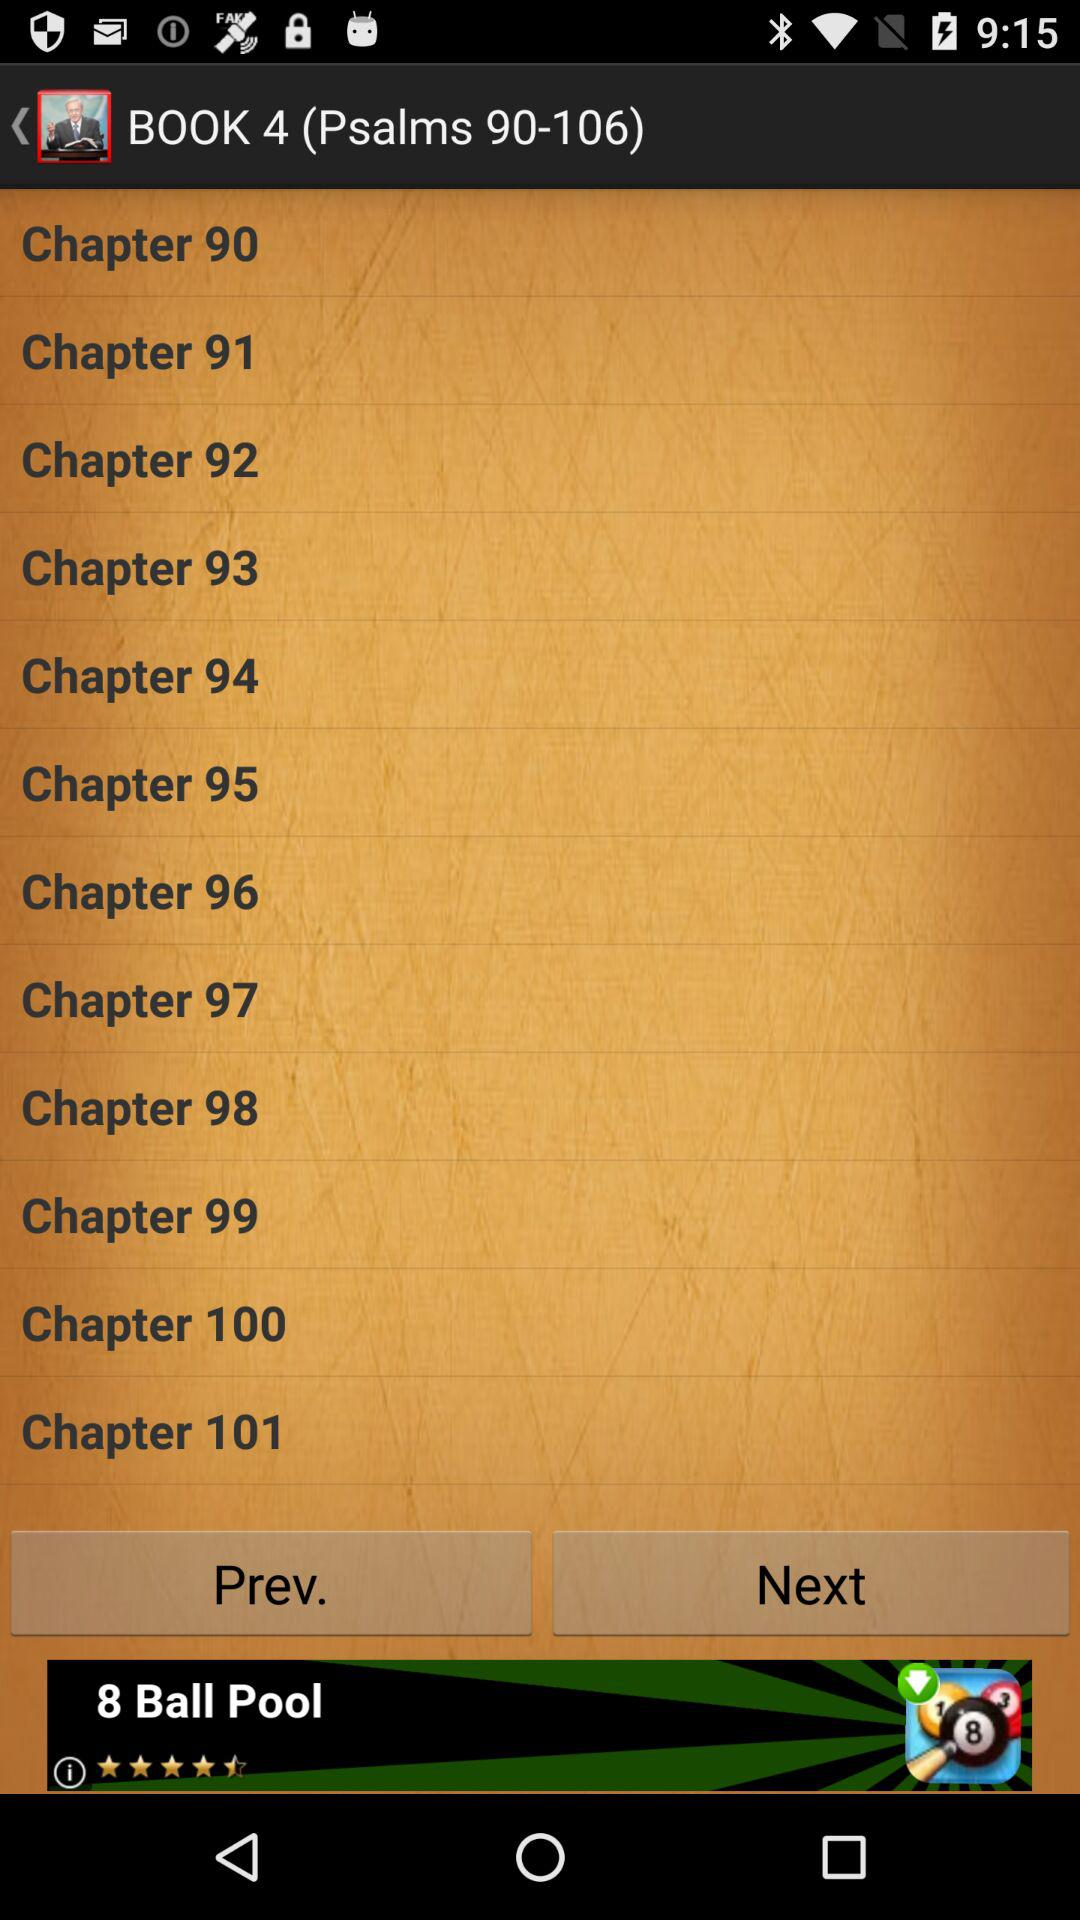How many books are in the Psalms collection?
Answer the question using a single word or phrase. 5 